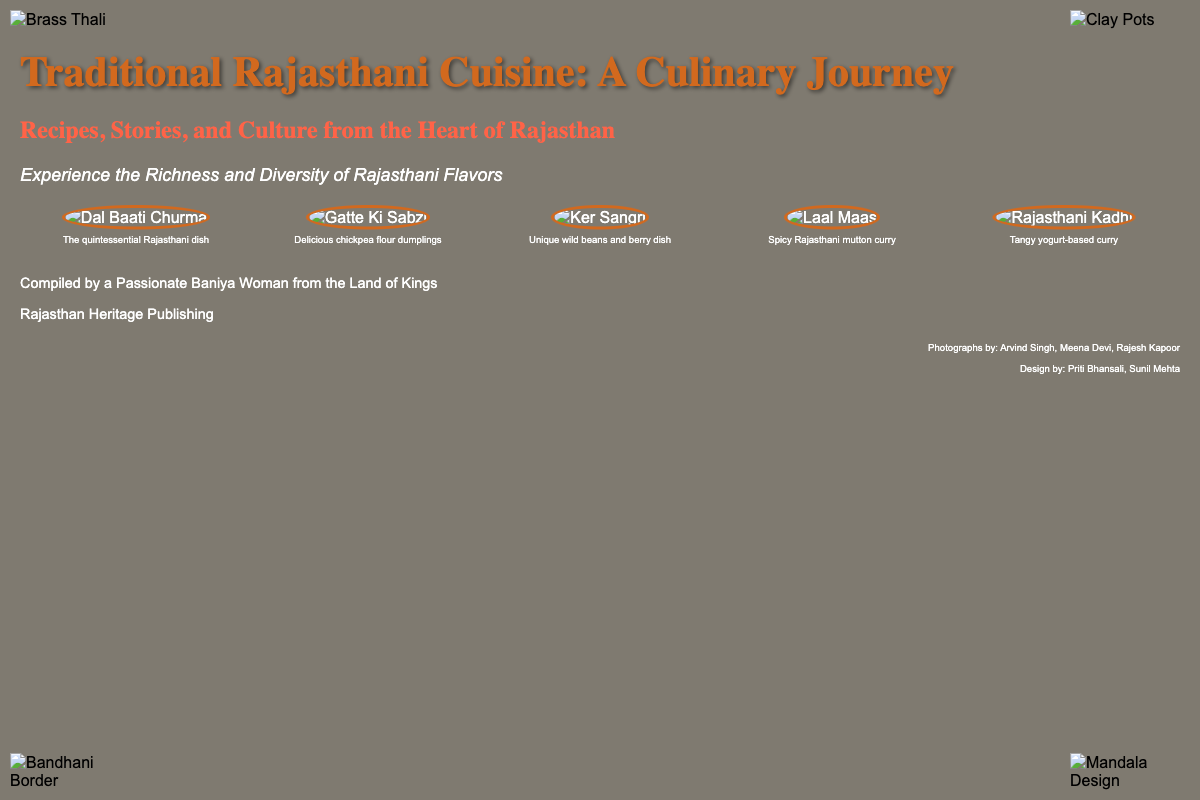What is the title of the book? The title of the book is prominently displayed on the cover.
Answer: Traditional Rajasthani Cuisine: A Culinary Journey Who compiled the book? The author's name is mentioned in the author section on the cover.
Answer: A Passionate Baniya Woman from the Land of Kings What dish is known as the quintessential Rajasthani dish? The dish is identified in the dishes section with its caption.
Answer: Dal Baati Churma How many dishes are shown on the cover? The cover displays a total of five different dishes in the dishes section.
Answer: Five Which publisher published the book? The publisher's name is mentioned near the bottom of the cover.
Answer: Rajasthan Heritage Publishing What type of cuisine is featured in this book? The genre of cuisine is indicated in the title and subtitle of the cover.
Answer: Rajasthani What color is the overlay on the book cover? The color of the overlay that covers the background is clearly described.
Answer: Black (rgba(0,0,0,0.5)) What style is the subtitle written in? The style of the subtitle can be inferred from its presentation in the document.
Answer: Italic Which dish is a spicy Rajasthani mutton curry? The dish is identified with an image and its caption in the dishes section.
Answer: Laal Maas What type of design elements are featured in the corners? The types of decorative elements used are indicated by their labels.
Answer: Brass Thali, Clay Pots, Bandhani Border, Mandala Design 